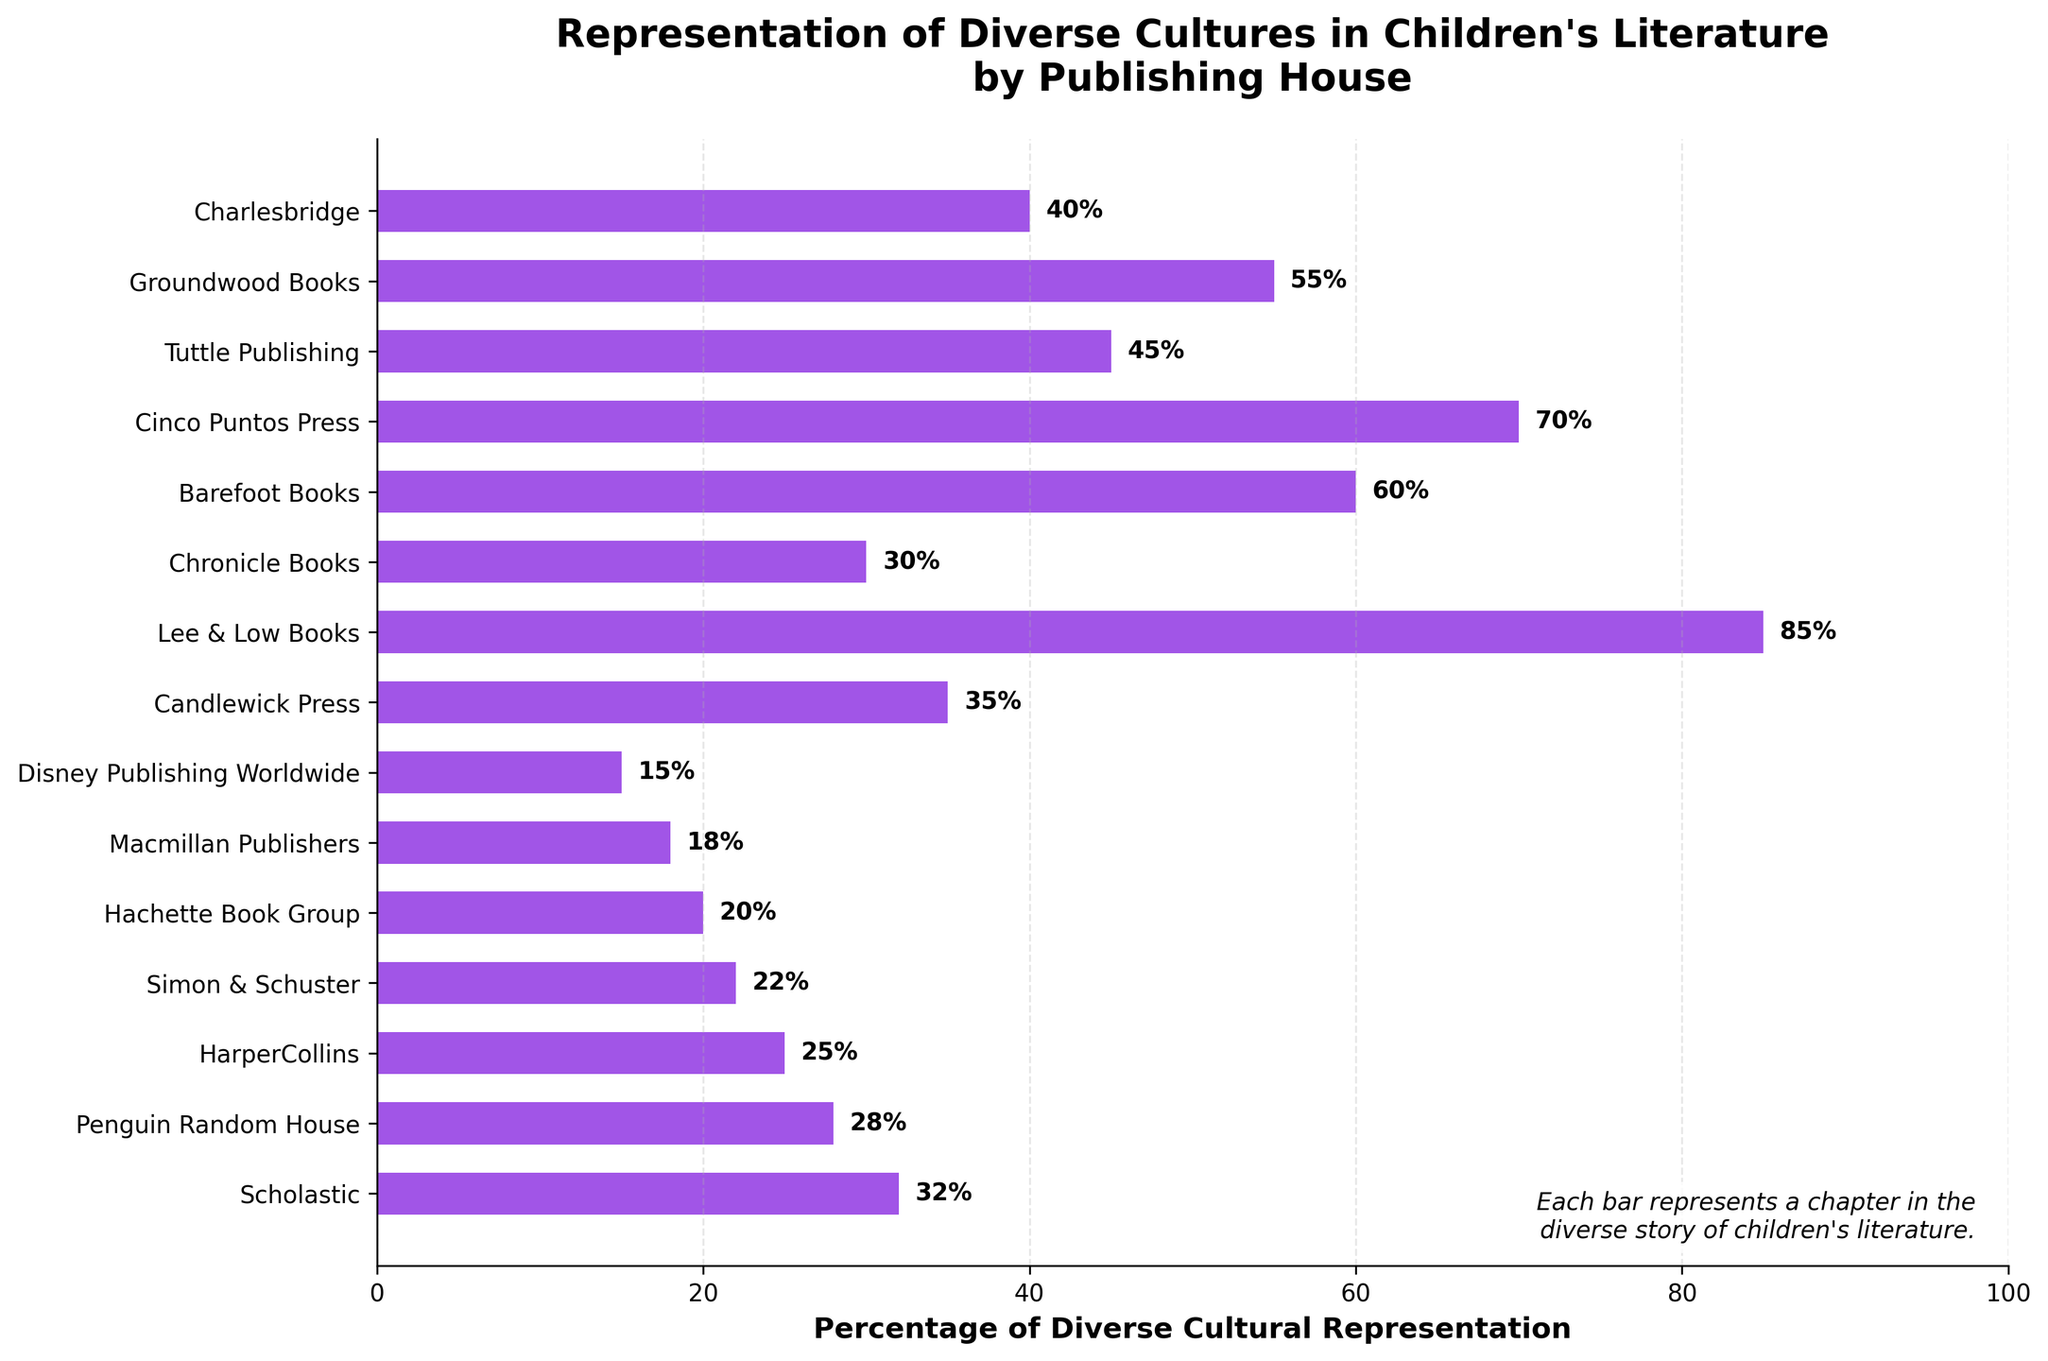Which publishing house has the highest percentage of diverse cultural representation? Observing the bar chart, the publishing house with the longest bar is Lee & Low Books. The end of the bar corresponds to the highest percentage value.
Answer: Lee & Low Books How does the percentage of diverse cultural representation for HarperCollins compare to Simon & Schuster? By comparing the length of the bars for HarperCollins and Simon & Schuster, HarperCollins has a slightly longer bar, indicating a higher percentage.
Answer: Higher What is the sum of the percentages of diverse cultural representation for Candlewick Press and Charlesbridge? Candlewick Press has a percentage of 35%, and Charlesbridge has a percentage of 40%. Summing these values gives 35 + 40.
Answer: 75% Which publishing houses have a percentage of diverse cultural representation above 50%? Observing the lengths of the bars, Lee & Low Books (85%), Barefoot Books (60%), Cinco Puntos Press (70%), and Groundwood Books (55%) exceed the 50% mark.
Answer: Lee & Low Books, Barefoot Books, Cinco Puntos Press, and Groundwood Books What is the average percentage of diverse cultural representation across all publishing houses? Sum of percentages: 32 + 28 + 25 + 22 + 20 + 18 + 15 + 35 + 85 + 30 + 60 + 70 + 45 + 55 + 40 = 580. Divide by the total number of publishers, 15: 580/15 = 38.67
Answer: 38.67% Which publisher represents diverse cultures the least, and what is the percentage? The shortest bar on the chart corresponds to Disney Publishing Worldwide, which has a percentage of 15%.
Answer: Disney Publishing Worldwide, 15% Is the percentage of diverse cultural representation for Penguin Random House closer to Scholastic or HarperCollins? Penguin Random House (28%) is compared with Scholastic (32%) and HarperCollins (25%). The difference between Penguin and Scholastic is 4%, and between Penguin and HarperCollins is 3%. Therefore, it is closer to HarperCollins.
Answer: HarperCollins What is the difference in diverse cultural representation between the top two publishing houses? The top two are Lee & Low Books (85%) and Cinco Puntos Press (70%). The difference is calculated as 85 - 70.
Answer: 15% Which publishing house has a greater percentage representation, Tuttle Publishing or Chronicle Books? Comparing the lengths of the bars, Tuttle Publishing has a percentage of 45%, and Chronicle Books has 30%. Tuttle Publishing has a greater representation.
Answer: Tuttle Publishing 